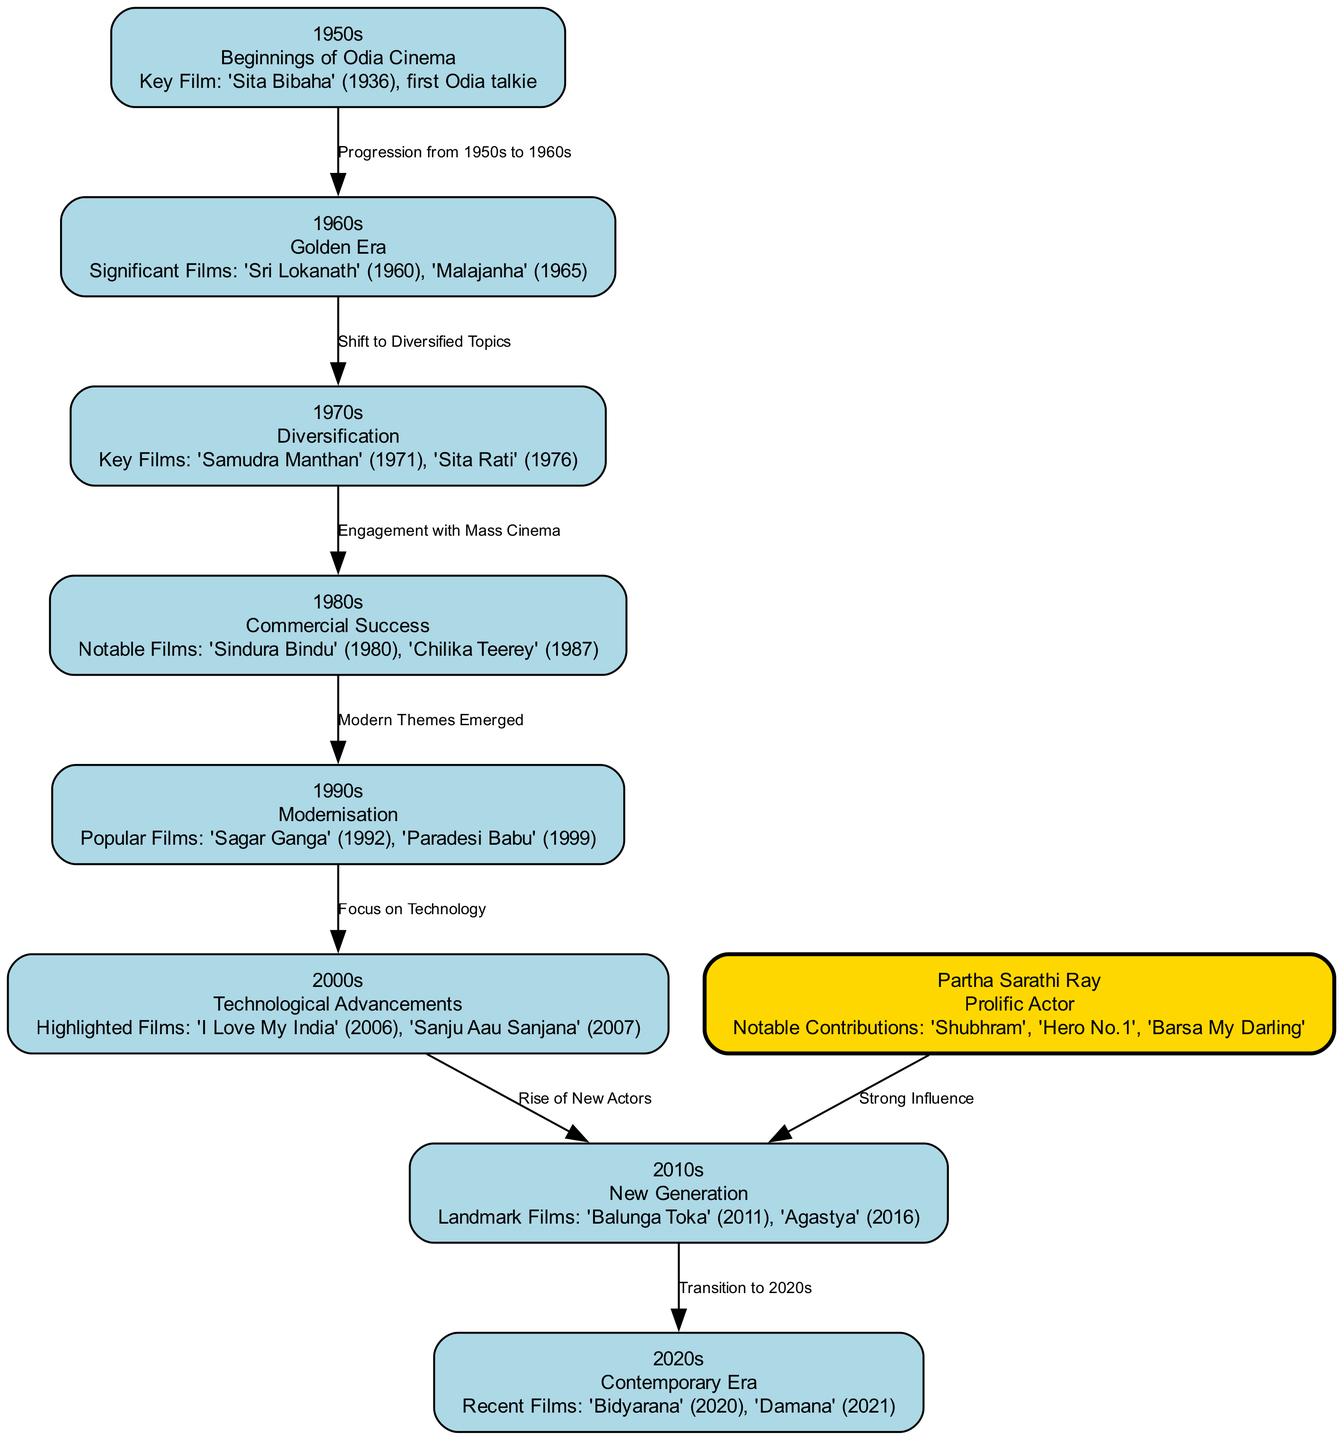What significant film made its debut in the 1950s? The diagram indicates that the key film of the 1950s is "Sita Bibaha," which was the first Odia talkie.
Answer: Sita Bibaha How many nodes are there in the diagram? Counting each distinct period and character featured in the diagram, there are a total of 9 nodes representing different eras and contributions to Odia cinema.
Answer: 9 Which decade is referred to as the "Golden Era" of Odia cinema? In the diagram, the 1960s is specifically labeled as the "Golden Era," signaling its prominence in the evolution of Odia films.
Answer: 1960s What notable contribution did Partha Sarathi Ray make? According to the diagram, Partha Sarathi Ray made significant contributions through films like "Shubhram," "Hero No.1," and "Barsa My Darling."
Answer: Shubhram, Hero No.1, Barsa My Darling What relationship does the 1980s have with the 1990s in terms of film themes? The diagram specifies that the 1980s transition into the 1990s shows a shift towards "Modern Themes Emerged," highlighting a developing narrative within the cinema.
Answer: Modern Themes Emerged Which films are highlighted in the 2000s? The diagram lists "I Love My India" (2006) and "Sanju Aau Sanjana" (2007) as highlighted films in the 2000s.
Answer: I Love My India, Sanju Aau Sanjana How did the filmmaking landscape evolve from the 1960s to the 1970s? From the 1960s described as the "Golden Era," the diagram shows a progression to the 1970s, characterized by a "Shift to Diversified Topics," reflecting broader storytelling in films.
Answer: Shift to Diversified Topics Which decade features the film "Bidyarana"? The diagram indicates that "Bidyarana" is a recent film associated with the contemporary era of the 2020s.
Answer: 2020s What signifies the transition from the 2000s to the 2010s? The diagram marks the shift from the 2000s to the 2010s with the rise of "New Actors," indicating a fresh wave of talent and performances in Odia films.
Answer: New Actors 